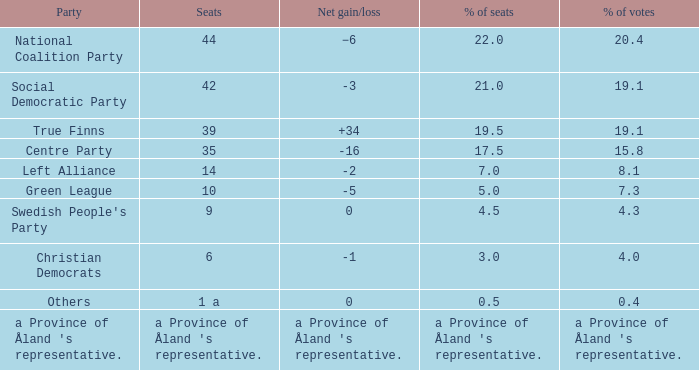In relation to the seats that received 14.0. 